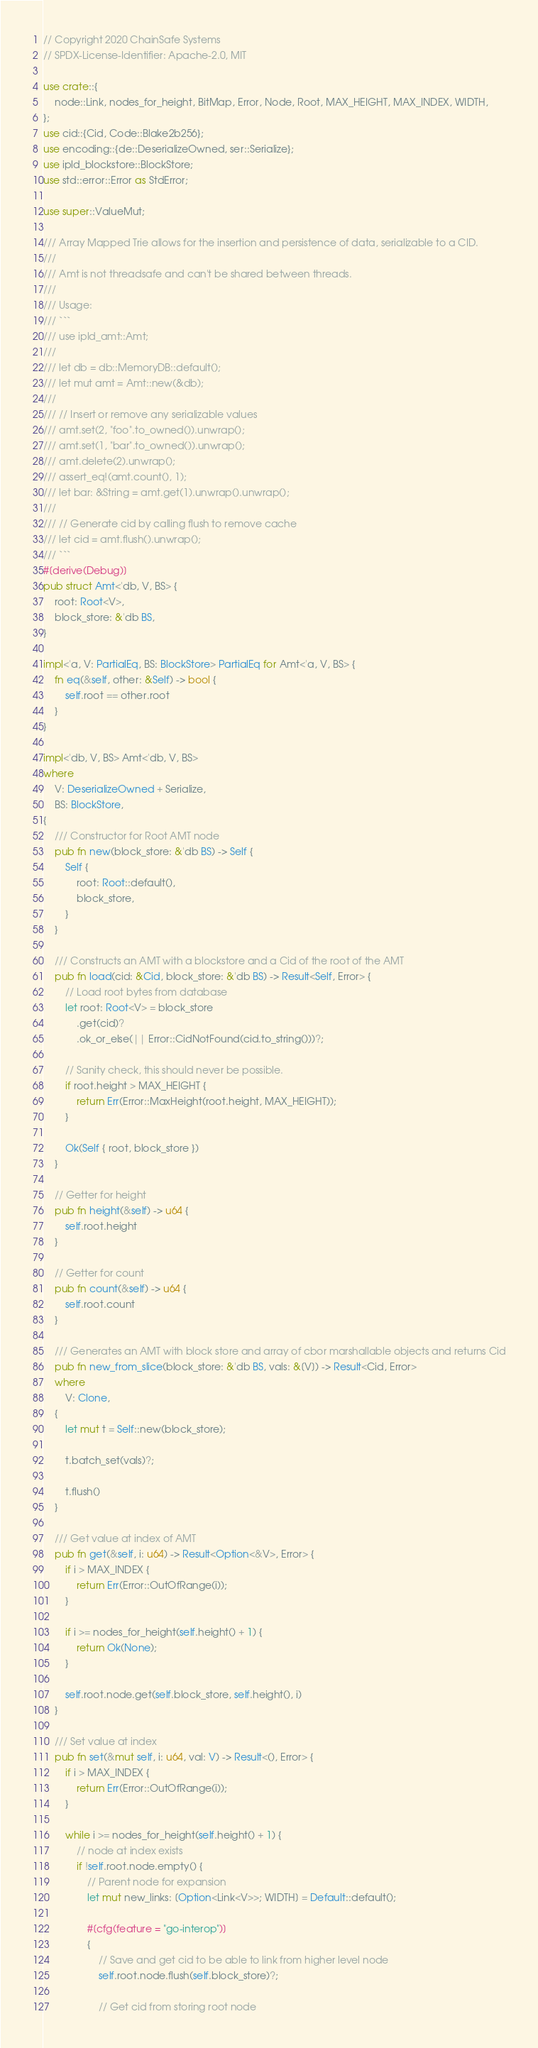<code> <loc_0><loc_0><loc_500><loc_500><_Rust_>// Copyright 2020 ChainSafe Systems
// SPDX-License-Identifier: Apache-2.0, MIT

use crate::{
    node::Link, nodes_for_height, BitMap, Error, Node, Root, MAX_HEIGHT, MAX_INDEX, WIDTH,
};
use cid::{Cid, Code::Blake2b256};
use encoding::{de::DeserializeOwned, ser::Serialize};
use ipld_blockstore::BlockStore;
use std::error::Error as StdError;

use super::ValueMut;

/// Array Mapped Trie allows for the insertion and persistence of data, serializable to a CID.
///
/// Amt is not threadsafe and can't be shared between threads.
///
/// Usage:
/// ```
/// use ipld_amt::Amt;
///
/// let db = db::MemoryDB::default();
/// let mut amt = Amt::new(&db);
///
/// // Insert or remove any serializable values
/// amt.set(2, "foo".to_owned()).unwrap();
/// amt.set(1, "bar".to_owned()).unwrap();
/// amt.delete(2).unwrap();
/// assert_eq!(amt.count(), 1);
/// let bar: &String = amt.get(1).unwrap().unwrap();
///
/// // Generate cid by calling flush to remove cache
/// let cid = amt.flush().unwrap();
/// ```
#[derive(Debug)]
pub struct Amt<'db, V, BS> {
    root: Root<V>,
    block_store: &'db BS,
}

impl<'a, V: PartialEq, BS: BlockStore> PartialEq for Amt<'a, V, BS> {
    fn eq(&self, other: &Self) -> bool {
        self.root == other.root
    }
}

impl<'db, V, BS> Amt<'db, V, BS>
where
    V: DeserializeOwned + Serialize,
    BS: BlockStore,
{
    /// Constructor for Root AMT node
    pub fn new(block_store: &'db BS) -> Self {
        Self {
            root: Root::default(),
            block_store,
        }
    }

    /// Constructs an AMT with a blockstore and a Cid of the root of the AMT
    pub fn load(cid: &Cid, block_store: &'db BS) -> Result<Self, Error> {
        // Load root bytes from database
        let root: Root<V> = block_store
            .get(cid)?
            .ok_or_else(|| Error::CidNotFound(cid.to_string()))?;

        // Sanity check, this should never be possible.
        if root.height > MAX_HEIGHT {
            return Err(Error::MaxHeight(root.height, MAX_HEIGHT));
        }

        Ok(Self { root, block_store })
    }

    // Getter for height
    pub fn height(&self) -> u64 {
        self.root.height
    }

    // Getter for count
    pub fn count(&self) -> u64 {
        self.root.count
    }

    /// Generates an AMT with block store and array of cbor marshallable objects and returns Cid
    pub fn new_from_slice(block_store: &'db BS, vals: &[V]) -> Result<Cid, Error>
    where
        V: Clone,
    {
        let mut t = Self::new(block_store);

        t.batch_set(vals)?;

        t.flush()
    }

    /// Get value at index of AMT
    pub fn get(&self, i: u64) -> Result<Option<&V>, Error> {
        if i > MAX_INDEX {
            return Err(Error::OutOfRange(i));
        }

        if i >= nodes_for_height(self.height() + 1) {
            return Ok(None);
        }

        self.root.node.get(self.block_store, self.height(), i)
    }

    /// Set value at index
    pub fn set(&mut self, i: u64, val: V) -> Result<(), Error> {
        if i > MAX_INDEX {
            return Err(Error::OutOfRange(i));
        }

        while i >= nodes_for_height(self.height() + 1) {
            // node at index exists
            if !self.root.node.empty() {
                // Parent node for expansion
                let mut new_links: [Option<Link<V>>; WIDTH] = Default::default();

                #[cfg(feature = "go-interop")]
                {
                    // Save and get cid to be able to link from higher level node
                    self.root.node.flush(self.block_store)?;

                    // Get cid from storing root node</code> 